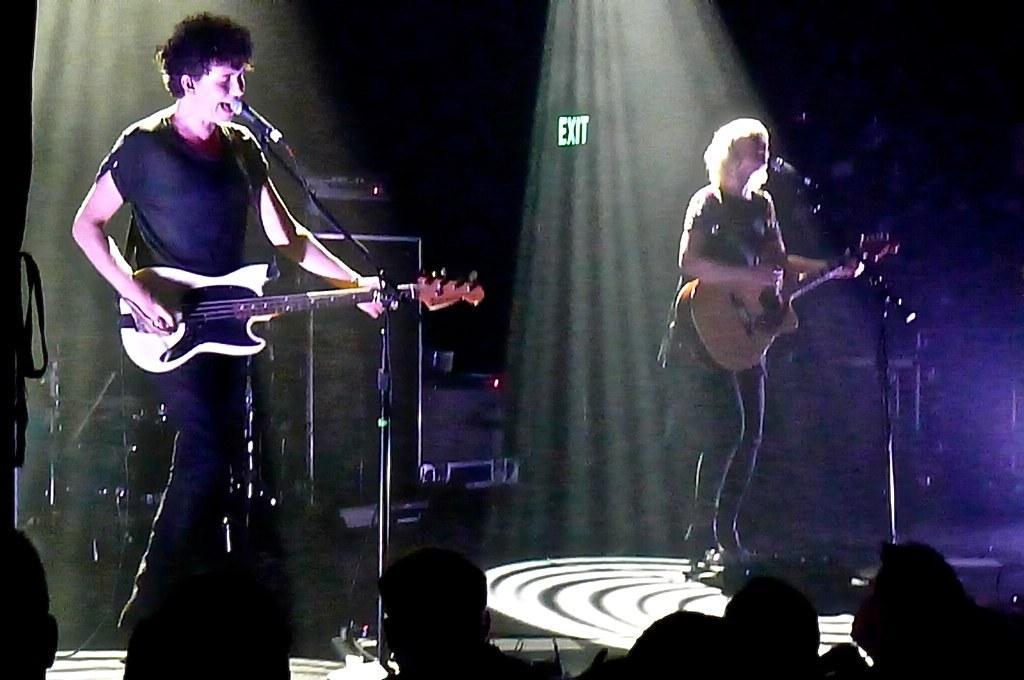Could you give a brief overview of what you see in this image? In this image on the left side there is one man who is standing and he is holding a guitar in front of him there is one mike it seems that he is singing. On the right side there is one woman who is standing and she is holding a guitar in front of her there is one mike. On the background there are some lights and in the bottom of the image there are some persons and on the left side of the image there are some sound systems. 